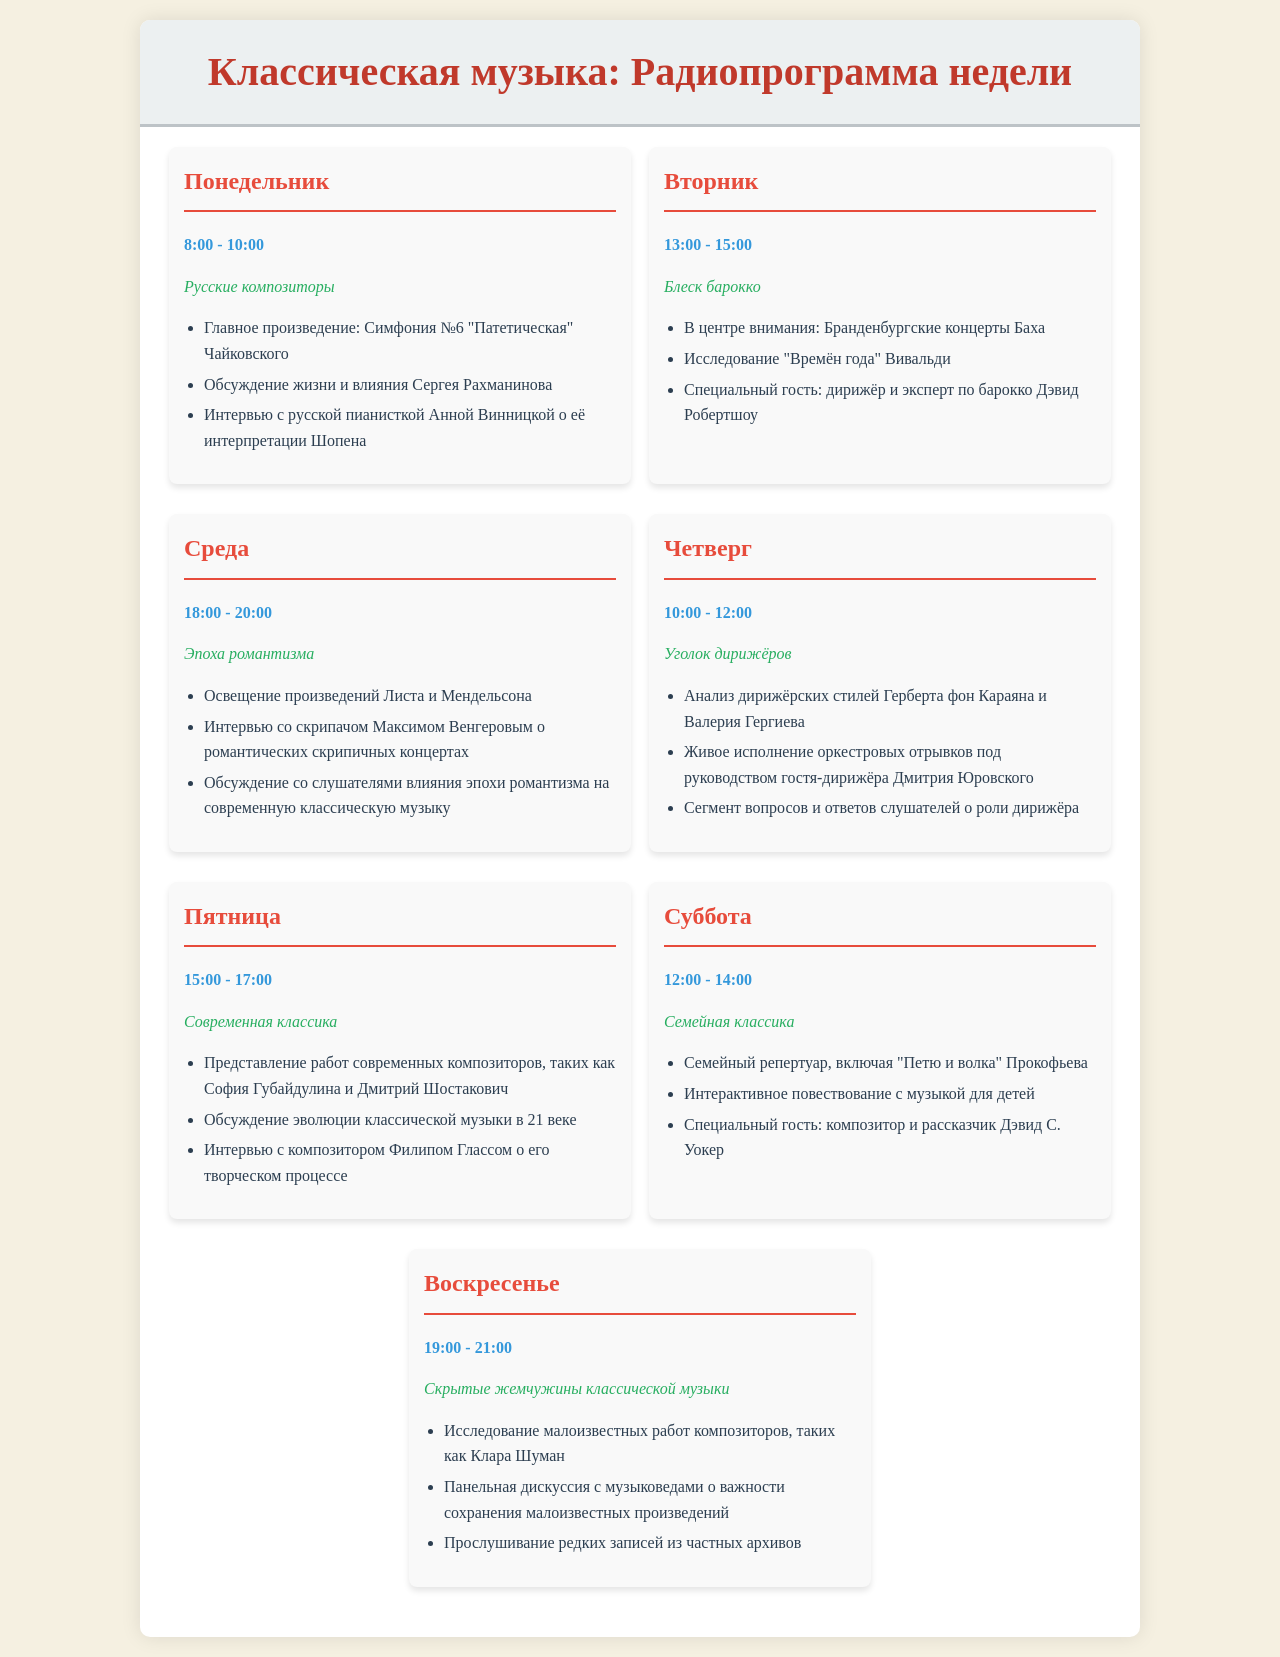what is the main theme for Monday? The theme for Monday is listed prominently beneath the day heading, which is "Русские композиторы".
Answer: Русские композиторы who is the special guest on Tuesday? The document notes that a special guest will appear on Tuesday, specifically a conductor and baroque expert named David Robertshaw.
Answer: Дэвид Робертшоу what time is the Friday show? The time for the Friday show is specified in the schedule, which is from 15:00 to 17:00.
Answer: 15:00 - 17:00 which major work is featured on Monday? The schedule highlights "Симфония №6 'Патетическая' Чайковского" as the main work for Monday.
Answer: Симфония №6 "Патетическая" Чайковского how many days are dedicated to classical music genres? The schedule outlines themed programming for each day of the week, amounting to a total of seven days.
Answer: семь what is discussed on Wednesday? The schedule specifies that it will cover works by Liszt and Mendelssohn on Wednesday.
Answer: произведений Листа и Мендельсона who is interviewed on Thursday? The Thursday episode will include a segment where the famous conductor Dmitry Yurovsky answers questions, indicating he will be the interviewee.
Answer: Дмитрий Юровский 